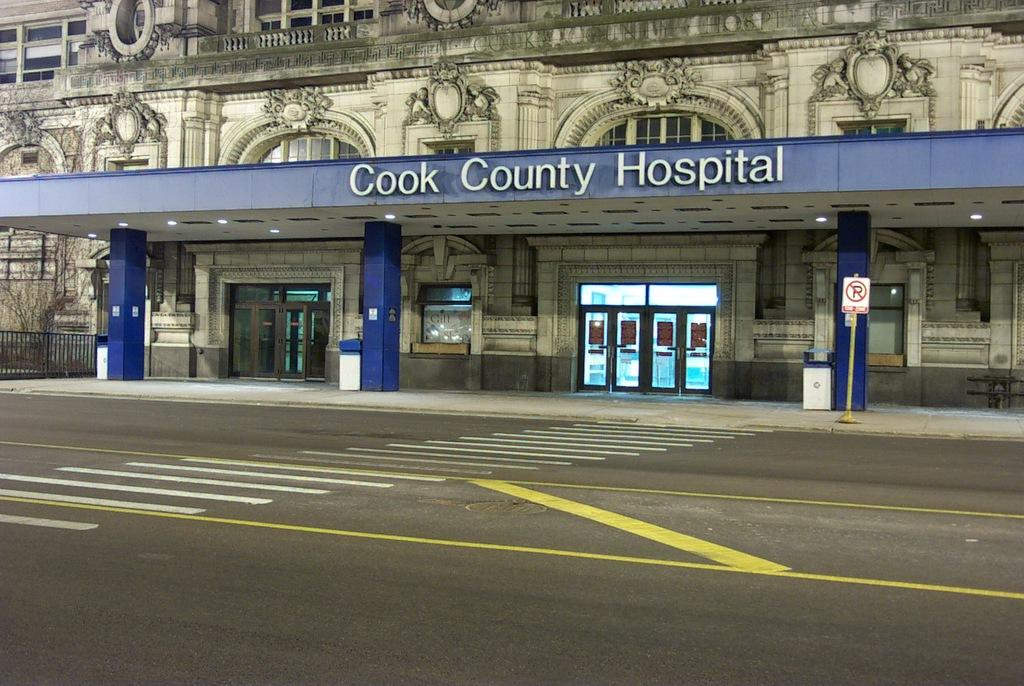<image>
Summarize the visual content of the image. The entrance to Cook County Hospital has a pull up area with a blue overhead. 